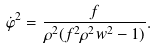<formula> <loc_0><loc_0><loc_500><loc_500>\dot { \varphi } ^ { 2 } = \frac { f } { \rho ^ { 2 } ( f ^ { 2 } \rho ^ { 2 } w ^ { 2 } - 1 ) } .</formula> 